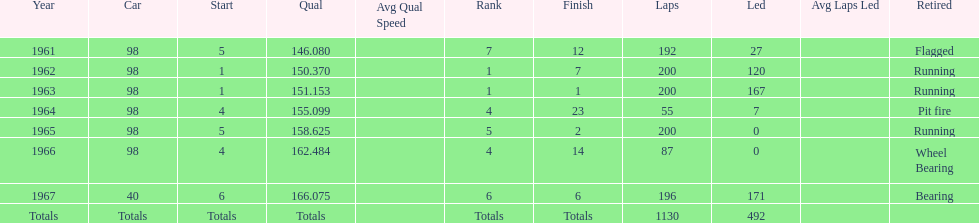In which years did he lead the race the least? 1965, 1966. 